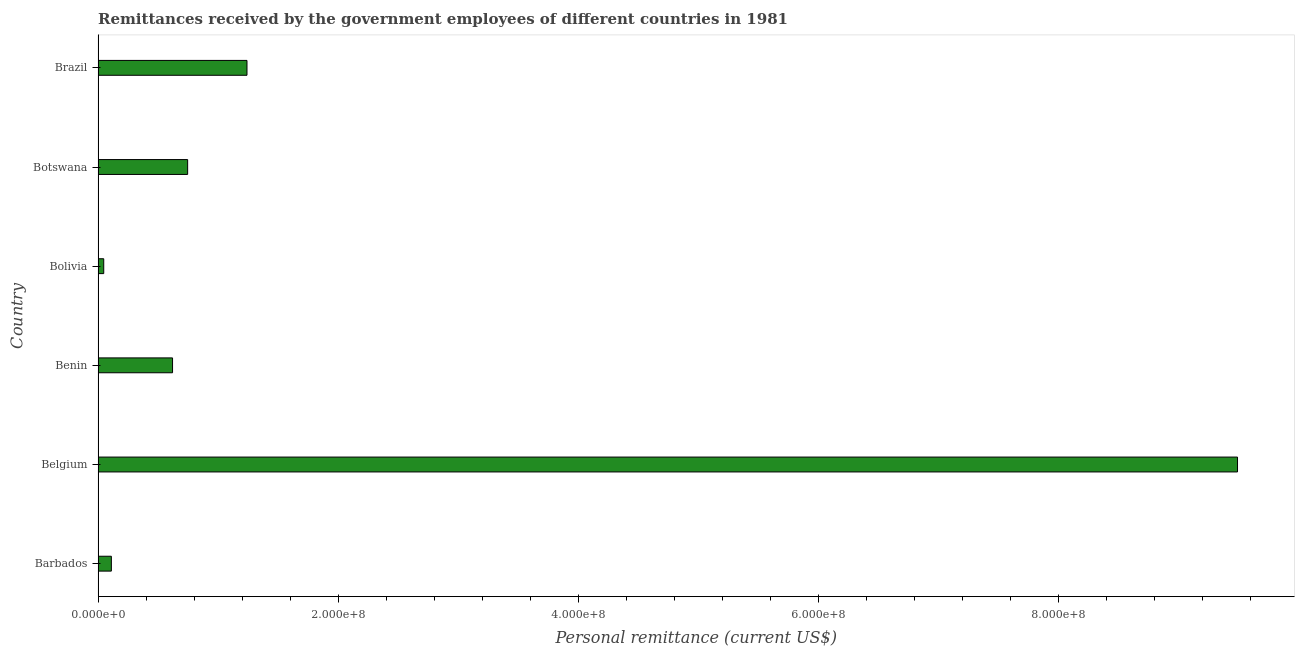Does the graph contain any zero values?
Offer a very short reply. No. Does the graph contain grids?
Give a very brief answer. No. What is the title of the graph?
Give a very brief answer. Remittances received by the government employees of different countries in 1981. What is the label or title of the X-axis?
Ensure brevity in your answer.  Personal remittance (current US$). What is the label or title of the Y-axis?
Offer a very short reply. Country. What is the personal remittances in Benin?
Make the answer very short. 6.20e+07. Across all countries, what is the maximum personal remittances?
Your response must be concise. 9.49e+08. Across all countries, what is the minimum personal remittances?
Your answer should be very brief. 4.70e+06. In which country was the personal remittances maximum?
Make the answer very short. Belgium. In which country was the personal remittances minimum?
Ensure brevity in your answer.  Bolivia. What is the sum of the personal remittances?
Offer a very short reply. 1.23e+09. What is the difference between the personal remittances in Botswana and Brazil?
Offer a terse response. -4.94e+07. What is the average personal remittances per country?
Your response must be concise. 2.04e+08. What is the median personal remittances?
Make the answer very short. 6.83e+07. What is the ratio of the personal remittances in Barbados to that in Bolivia?
Keep it short and to the point. 2.35. Is the personal remittances in Botswana less than that in Brazil?
Your answer should be compact. Yes. Is the difference between the personal remittances in Botswana and Brazil greater than the difference between any two countries?
Your answer should be compact. No. What is the difference between the highest and the second highest personal remittances?
Offer a terse response. 8.25e+08. Is the sum of the personal remittances in Barbados and Benin greater than the maximum personal remittances across all countries?
Make the answer very short. No. What is the difference between the highest and the lowest personal remittances?
Give a very brief answer. 9.44e+08. In how many countries, is the personal remittances greater than the average personal remittances taken over all countries?
Provide a succinct answer. 1. How many bars are there?
Ensure brevity in your answer.  6. Are all the bars in the graph horizontal?
Your response must be concise. Yes. How many countries are there in the graph?
Offer a very short reply. 6. Are the values on the major ticks of X-axis written in scientific E-notation?
Ensure brevity in your answer.  Yes. What is the Personal remittance (current US$) of Barbados?
Ensure brevity in your answer.  1.11e+07. What is the Personal remittance (current US$) of Belgium?
Offer a very short reply. 9.49e+08. What is the Personal remittance (current US$) of Benin?
Offer a terse response. 6.20e+07. What is the Personal remittance (current US$) of Bolivia?
Ensure brevity in your answer.  4.70e+06. What is the Personal remittance (current US$) in Botswana?
Your answer should be very brief. 7.46e+07. What is the Personal remittance (current US$) of Brazil?
Ensure brevity in your answer.  1.24e+08. What is the difference between the Personal remittance (current US$) in Barbados and Belgium?
Offer a terse response. -9.38e+08. What is the difference between the Personal remittance (current US$) in Barbados and Benin?
Provide a short and direct response. -5.10e+07. What is the difference between the Personal remittance (current US$) in Barbados and Bolivia?
Your answer should be very brief. 6.35e+06. What is the difference between the Personal remittance (current US$) in Barbados and Botswana?
Provide a short and direct response. -6.35e+07. What is the difference between the Personal remittance (current US$) in Barbados and Brazil?
Ensure brevity in your answer.  -1.13e+08. What is the difference between the Personal remittance (current US$) in Belgium and Benin?
Keep it short and to the point. 8.87e+08. What is the difference between the Personal remittance (current US$) in Belgium and Bolivia?
Your answer should be very brief. 9.44e+08. What is the difference between the Personal remittance (current US$) in Belgium and Botswana?
Provide a succinct answer. 8.74e+08. What is the difference between the Personal remittance (current US$) in Belgium and Brazil?
Keep it short and to the point. 8.25e+08. What is the difference between the Personal remittance (current US$) in Benin and Bolivia?
Your answer should be compact. 5.73e+07. What is the difference between the Personal remittance (current US$) in Benin and Botswana?
Make the answer very short. -1.26e+07. What is the difference between the Personal remittance (current US$) in Benin and Brazil?
Give a very brief answer. -6.20e+07. What is the difference between the Personal remittance (current US$) in Bolivia and Botswana?
Give a very brief answer. -6.99e+07. What is the difference between the Personal remittance (current US$) in Bolivia and Brazil?
Offer a very short reply. -1.19e+08. What is the difference between the Personal remittance (current US$) in Botswana and Brazil?
Keep it short and to the point. -4.94e+07. What is the ratio of the Personal remittance (current US$) in Barbados to that in Belgium?
Keep it short and to the point. 0.01. What is the ratio of the Personal remittance (current US$) in Barbados to that in Benin?
Keep it short and to the point. 0.18. What is the ratio of the Personal remittance (current US$) in Barbados to that in Bolivia?
Ensure brevity in your answer.  2.35. What is the ratio of the Personal remittance (current US$) in Barbados to that in Botswana?
Your answer should be compact. 0.15. What is the ratio of the Personal remittance (current US$) in Barbados to that in Brazil?
Your answer should be very brief. 0.09. What is the ratio of the Personal remittance (current US$) in Belgium to that in Benin?
Your answer should be very brief. 15.3. What is the ratio of the Personal remittance (current US$) in Belgium to that in Bolivia?
Ensure brevity in your answer.  201.89. What is the ratio of the Personal remittance (current US$) in Belgium to that in Botswana?
Ensure brevity in your answer.  12.72. What is the ratio of the Personal remittance (current US$) in Belgium to that in Brazil?
Your response must be concise. 7.65. What is the ratio of the Personal remittance (current US$) in Benin to that in Bolivia?
Your answer should be very brief. 13.19. What is the ratio of the Personal remittance (current US$) in Benin to that in Botswana?
Provide a succinct answer. 0.83. What is the ratio of the Personal remittance (current US$) in Benin to that in Brazil?
Make the answer very short. 0.5. What is the ratio of the Personal remittance (current US$) in Bolivia to that in Botswana?
Offer a terse response. 0.06. What is the ratio of the Personal remittance (current US$) in Bolivia to that in Brazil?
Provide a short and direct response. 0.04. What is the ratio of the Personal remittance (current US$) in Botswana to that in Brazil?
Your response must be concise. 0.6. 